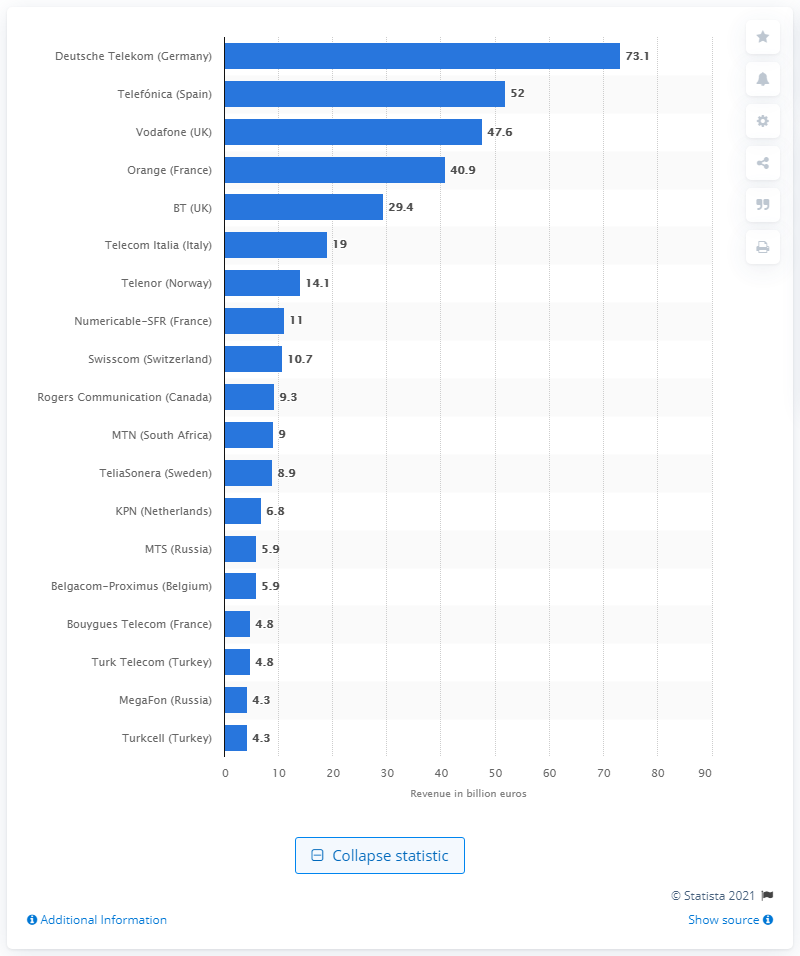Draw attention to some important aspects in this diagram. In 2016, Deutsche Telekom generated approximately 73.1 billion euros in revenue. 